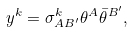Convert formula to latex. <formula><loc_0><loc_0><loc_500><loc_500>y ^ { k } = { \sigma } _ { A B ^ { \prime } } ^ { k } { \theta } ^ { A } { \bar { \theta } } ^ { B ^ { \prime } } ,</formula> 